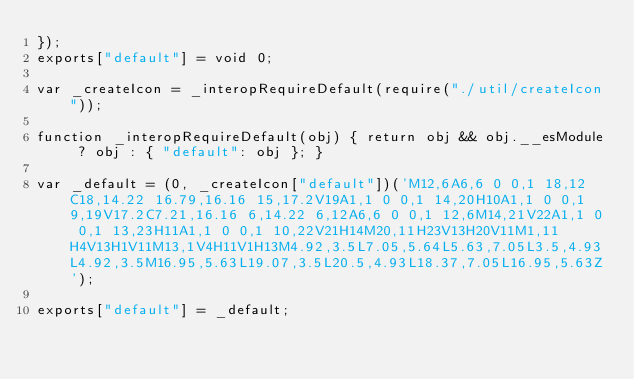<code> <loc_0><loc_0><loc_500><loc_500><_JavaScript_>});
exports["default"] = void 0;

var _createIcon = _interopRequireDefault(require("./util/createIcon"));

function _interopRequireDefault(obj) { return obj && obj.__esModule ? obj : { "default": obj }; }

var _default = (0, _createIcon["default"])('M12,6A6,6 0 0,1 18,12C18,14.22 16.79,16.16 15,17.2V19A1,1 0 0,1 14,20H10A1,1 0 0,1 9,19V17.2C7.21,16.16 6,14.22 6,12A6,6 0 0,1 12,6M14,21V22A1,1 0 0,1 13,23H11A1,1 0 0,1 10,22V21H14M20,11H23V13H20V11M1,11H4V13H1V11M13,1V4H11V1H13M4.92,3.5L7.05,5.64L5.63,7.05L3.5,4.93L4.92,3.5M16.95,5.63L19.07,3.5L20.5,4.93L18.37,7.05L16.95,5.63Z');

exports["default"] = _default;</code> 